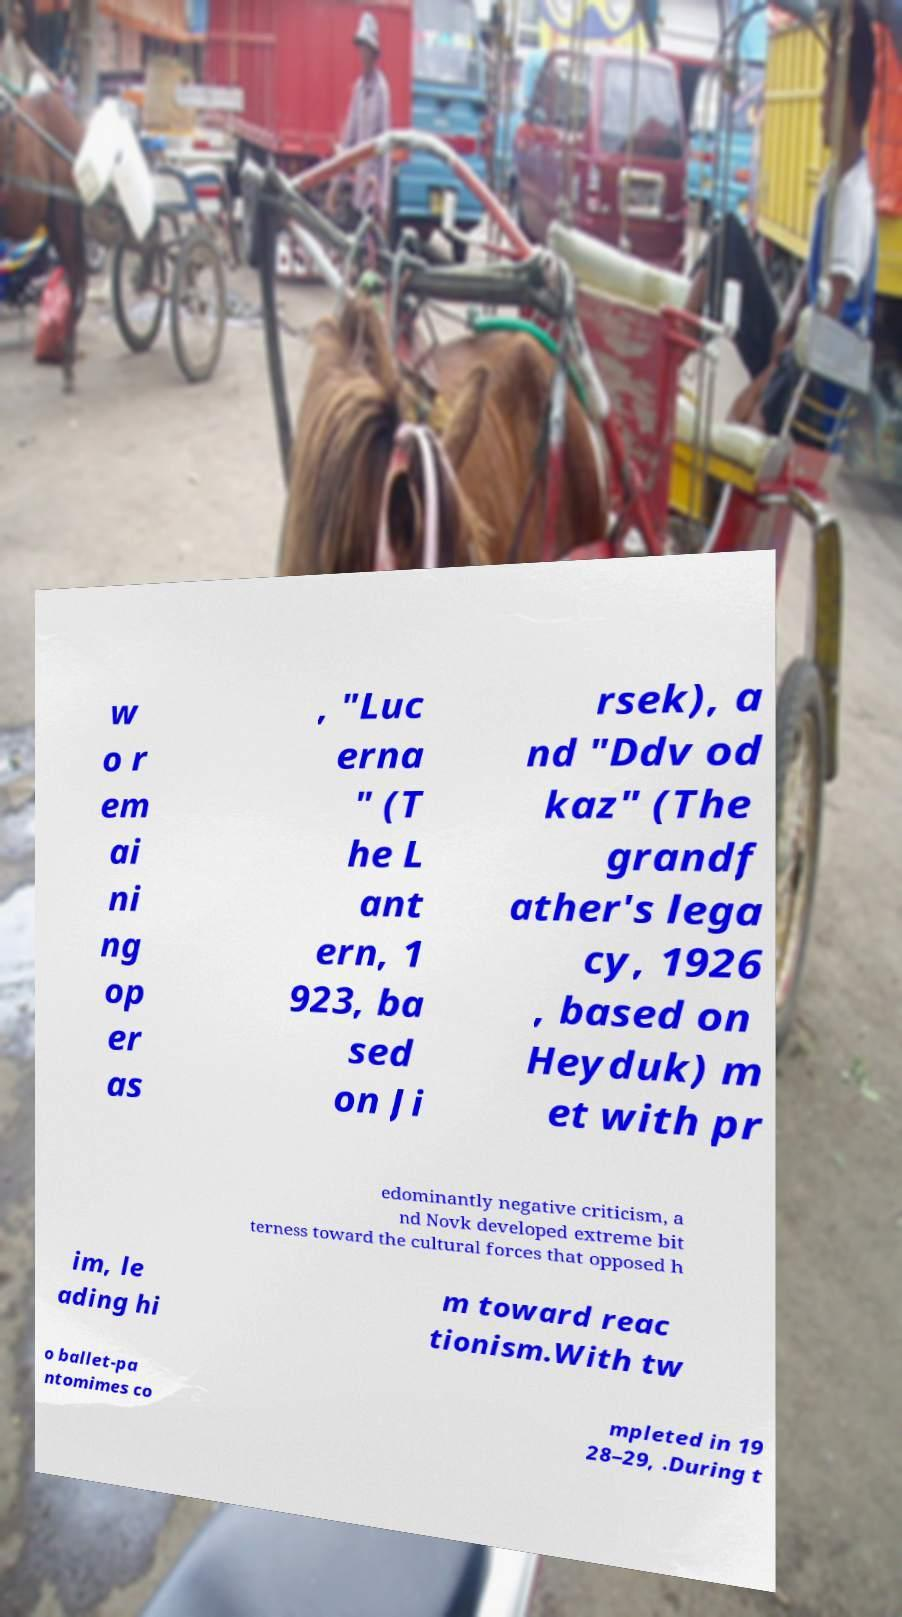Please read and relay the text visible in this image. What does it say? w o r em ai ni ng op er as , "Luc erna " (T he L ant ern, 1 923, ba sed on Ji rsek), a nd "Ddv od kaz" (The grandf ather's lega cy, 1926 , based on Heyduk) m et with pr edominantly negative criticism, a nd Novk developed extreme bit terness toward the cultural forces that opposed h im, le ading hi m toward reac tionism.With tw o ballet-pa ntomimes co mpleted in 19 28–29, .During t 